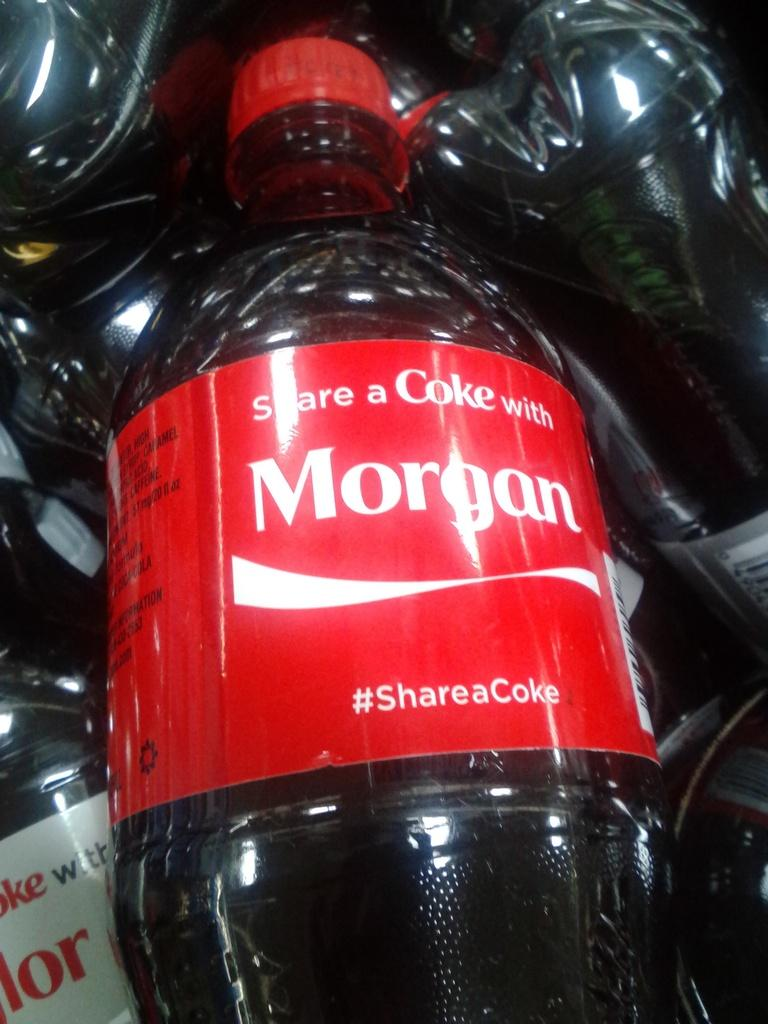What type of drinks are featured in the image? There are coke bottles in the image, which are described as preservative drinks. How many babies are present in the image? There are no babies present in the image; it features coke bottles. What type of insect can be seen interacting with the coke bottles in the image? There are no insects, such as bees, present in the image; it only features coke bottles. 